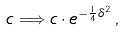Convert formula to latex. <formula><loc_0><loc_0><loc_500><loc_500>c \Longrightarrow c \cdot e ^ { - \frac { 1 } { 4 } \delta ^ { 2 } } \, ,</formula> 